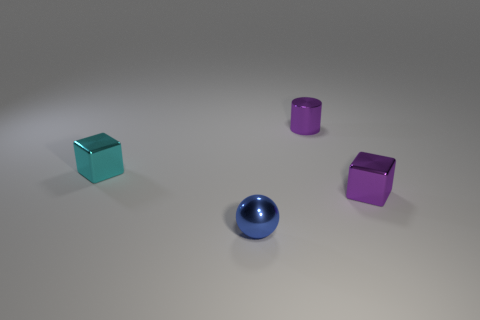There is a purple shiny thing that is the same size as the purple cylinder; what is its shape?
Provide a succinct answer. Cube. How many small cylinders have the same color as the sphere?
Offer a very short reply. 0. What number of purple cubes have the same size as the metallic cylinder?
Your answer should be compact. 1. There is a small sphere that is the same material as the tiny cylinder; what color is it?
Your response must be concise. Blue. Are there fewer small metallic spheres right of the blue metallic ball than blue matte cubes?
Offer a very short reply. No. What shape is the tiny cyan thing that is made of the same material as the small blue thing?
Your response must be concise. Cube. How many shiny things are either tiny balls or small green blocks?
Make the answer very short. 1. Are there an equal number of tiny blocks that are on the right side of the small metal sphere and blue metal things?
Make the answer very short. Yes. There is a tiny shiny cube in front of the cyan metal object; is its color the same as the small metallic cylinder?
Your answer should be very brief. Yes. What material is the tiny thing that is in front of the cylinder and right of the blue metal ball?
Make the answer very short. Metal. 